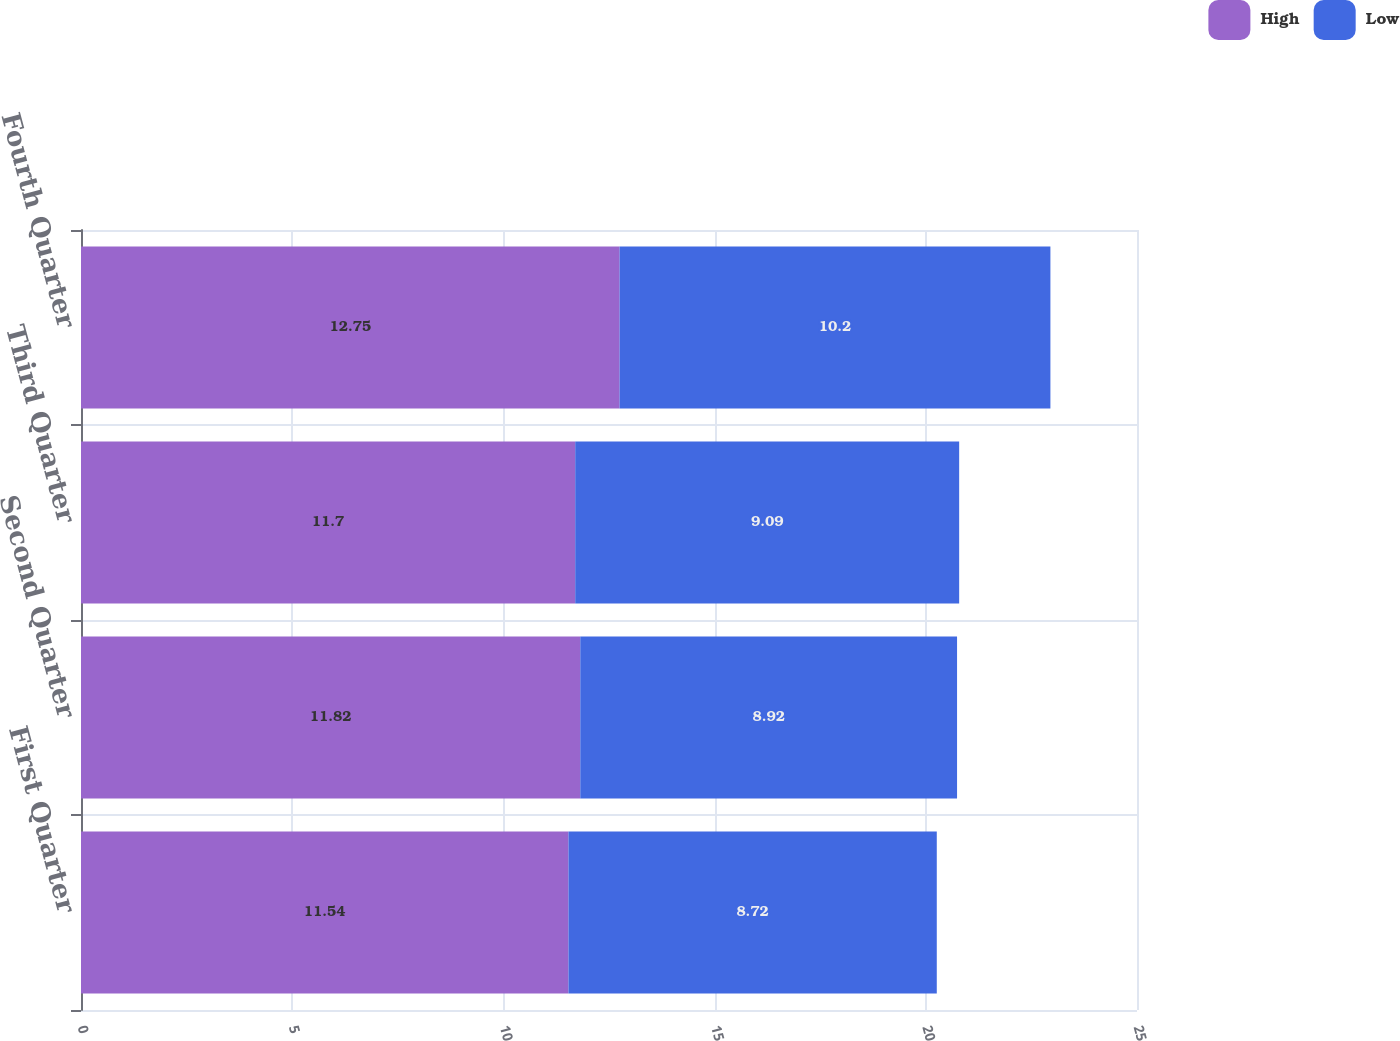Convert chart. <chart><loc_0><loc_0><loc_500><loc_500><stacked_bar_chart><ecel><fcel>First Quarter<fcel>Second Quarter<fcel>Third Quarter<fcel>Fourth Quarter<nl><fcel>High<fcel>11.54<fcel>11.82<fcel>11.7<fcel>12.75<nl><fcel>Low<fcel>8.72<fcel>8.92<fcel>9.09<fcel>10.2<nl></chart> 